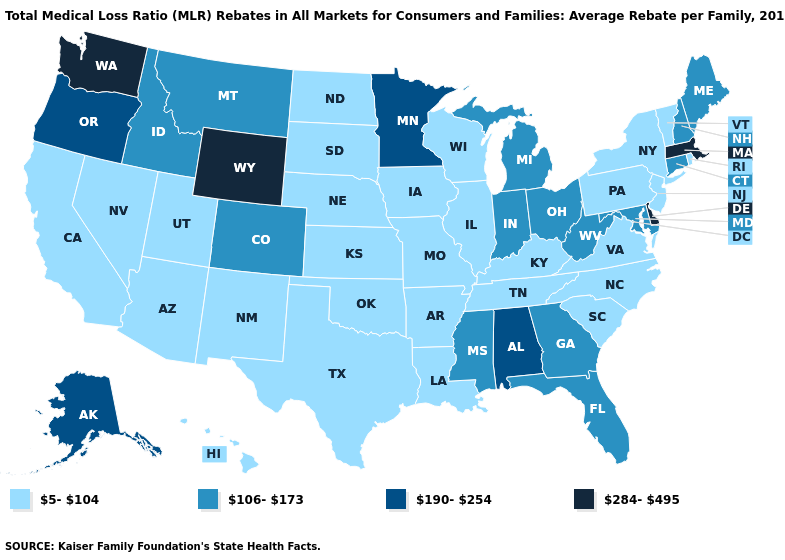Among the states that border Montana , does Wyoming have the highest value?
Short answer required. Yes. Does the map have missing data?
Answer briefly. No. Name the states that have a value in the range 106-173?
Answer briefly. Colorado, Connecticut, Florida, Georgia, Idaho, Indiana, Maine, Maryland, Michigan, Mississippi, Montana, New Hampshire, Ohio, West Virginia. How many symbols are there in the legend?
Give a very brief answer. 4. Among the states that border Iowa , does Minnesota have the highest value?
Give a very brief answer. Yes. Which states have the lowest value in the Northeast?
Answer briefly. New Jersey, New York, Pennsylvania, Rhode Island, Vermont. What is the value of Utah?
Give a very brief answer. 5-104. Name the states that have a value in the range 190-254?
Quick response, please. Alabama, Alaska, Minnesota, Oregon. Among the states that border Kentucky , does Illinois have the lowest value?
Keep it brief. Yes. Does Kentucky have the highest value in the South?
Short answer required. No. Which states have the lowest value in the USA?
Keep it brief. Arizona, Arkansas, California, Hawaii, Illinois, Iowa, Kansas, Kentucky, Louisiana, Missouri, Nebraska, Nevada, New Jersey, New Mexico, New York, North Carolina, North Dakota, Oklahoma, Pennsylvania, Rhode Island, South Carolina, South Dakota, Tennessee, Texas, Utah, Vermont, Virginia, Wisconsin. Among the states that border South Dakota , does Wyoming have the highest value?
Give a very brief answer. Yes. How many symbols are there in the legend?
Be succinct. 4. Is the legend a continuous bar?
Answer briefly. No. What is the value of Minnesota?
Quick response, please. 190-254. 